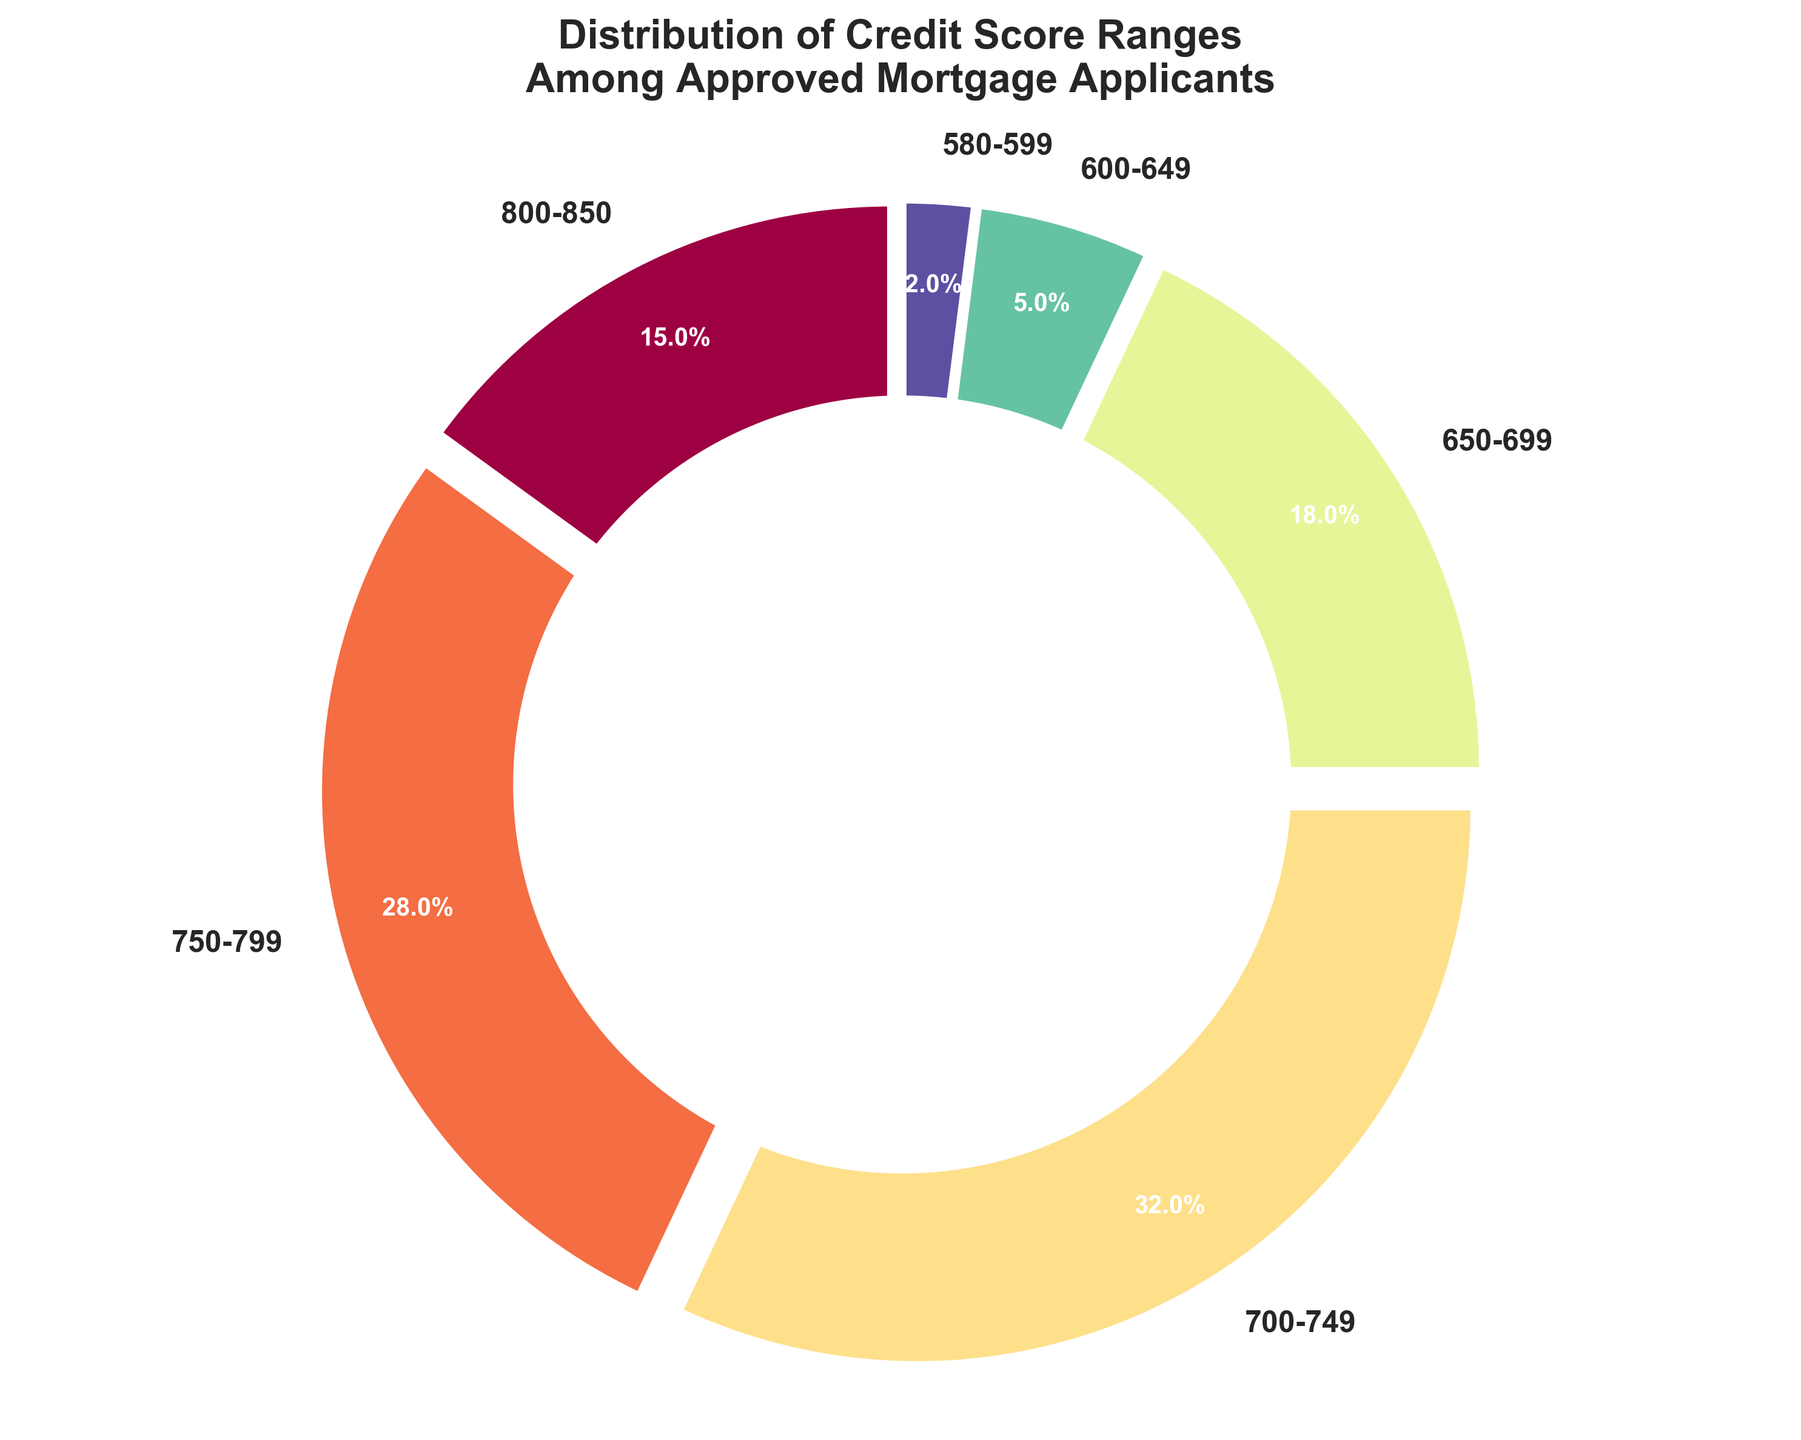Which credit score range has the highest percentage of approved applicants? To determine which credit score range has the highest percentage, we look for the segment that occupies the largest portion of the pie chart. According to the data, the range 700-749 covers the largest area with 32%.
Answer: 700-749 Which two adjacent credit score ranges have a combined percentage of less than 10%? We need to identify any two neighboring ranges that together make up less than 10%. The ranges 600-649 and 580-599 are adjacent and have percentages of 5% and 2% respectively, summing up to 7%, which is less than 10%.
Answer: 600-649 and 580-599 What percentage of approved applicants have a credit score below 650? We add the percentages of the ranges 600-649 and 580-599. According to the data, these percentages are 5% and 2% respectively, so the total is 5% + 2% = 7%.
Answer: 7% Are there more approved applicants in the 800-850 range or the 650-699 range, and by how much? To compare these two ranges, we subtract the percentage of the 800-850 range from the percentage of the 650-699 range. The percentages are 18% and 15% respectively, so the difference is 18% - 15% = 3%.
Answer: 650-699 by 3% What is the combined percentage of approved applicants in the top two credit score ranges? We add the percentages of the top two ranges, which are 700-749 and 750-799. According to the data, these percentages are 32% and 28% respectively, so the sum is 32% + 28% = 60%.
Answer: 60% How does the percentage of approved applicants with a score between 750-799 compare to those with a score between 650-699? We compare the percentages of the two ranges directly. The 750-799 range has 28%, while the 650-699 range has 18%. The 750-799 range is larger.
Answer: 750-799 is larger Which credit score ranges share the closest percentage values? We look for two ranges with the smallest difference in their percentages. The closets are 650-699 and 800-850 with 18% and 15% respectively, a difference of only 3%.
Answer: 650-699 and 800-850 What is the percentage difference between the range with the highest percentage and the range with the lowest percentage? The highest percentage range is 700-749 with 32%, and the lowest is 580-599 with 2%. The difference is calculated as 32% - 2% = 30%.
Answer: 30% If we combine the percentages of all applicants with scores above 750, what is the total percentage? We need to sum the percentages of the 750-799 and 800-850 ranges. According to the data, these percentages are 28% and 15% respectively, so the total is 28% + 15% = 43%.
Answer: 43% 